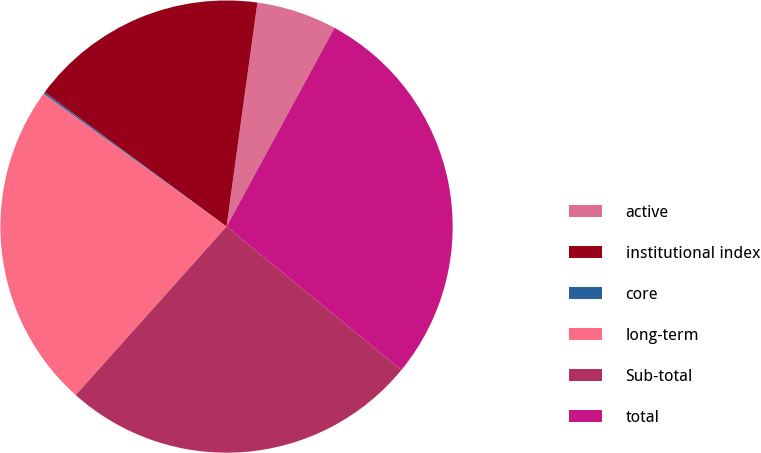Convert chart to OTSL. <chart><loc_0><loc_0><loc_500><loc_500><pie_chart><fcel>active<fcel>institutional index<fcel>core<fcel>long-term<fcel>Sub-total<fcel>total<nl><fcel>5.74%<fcel>17.06%<fcel>0.13%<fcel>23.37%<fcel>25.69%<fcel>28.01%<nl></chart> 